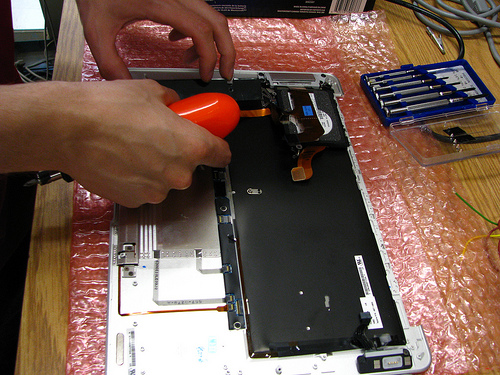<image>
Is there a finger on the board? Yes. Looking at the image, I can see the finger is positioned on top of the board, with the board providing support. Where is the screwdriver in relation to the finger? Is it in front of the finger? Yes. The screwdriver is positioned in front of the finger, appearing closer to the camera viewpoint. 